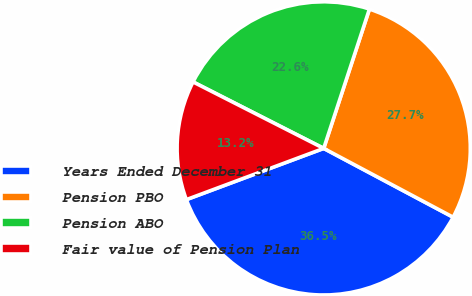<chart> <loc_0><loc_0><loc_500><loc_500><pie_chart><fcel>Years Ended December 31<fcel>Pension PBO<fcel>Pension ABO<fcel>Fair value of Pension Plan<nl><fcel>36.54%<fcel>27.73%<fcel>22.56%<fcel>13.17%<nl></chart> 